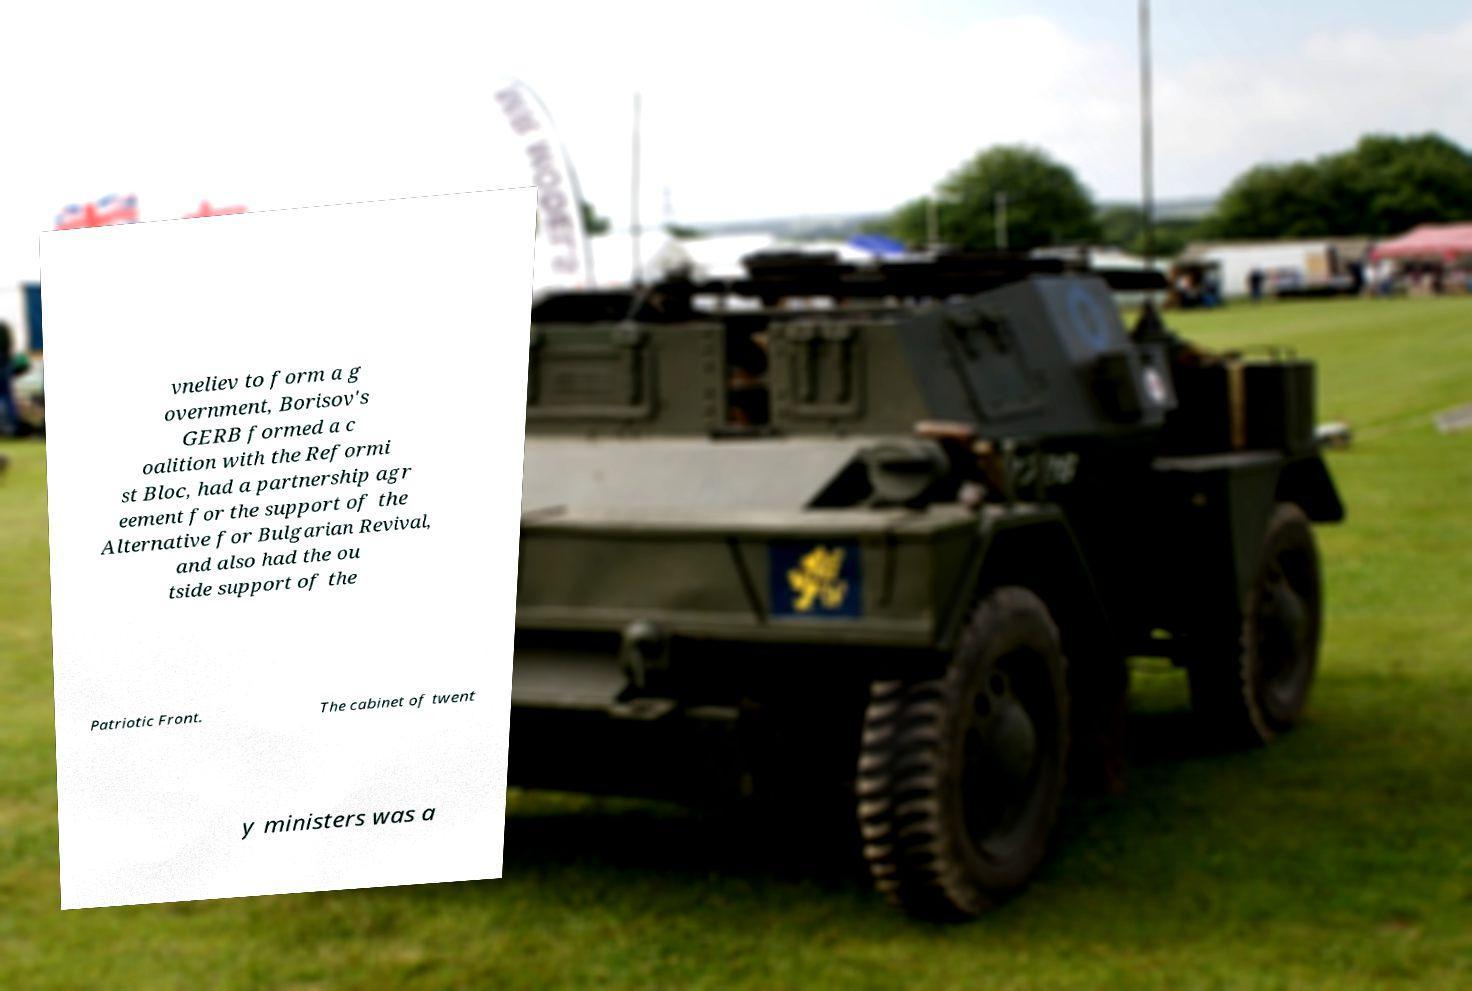Can you accurately transcribe the text from the provided image for me? vneliev to form a g overnment, Borisov's GERB formed a c oalition with the Reformi st Bloc, had a partnership agr eement for the support of the Alternative for Bulgarian Revival, and also had the ou tside support of the Patriotic Front. The cabinet of twent y ministers was a 